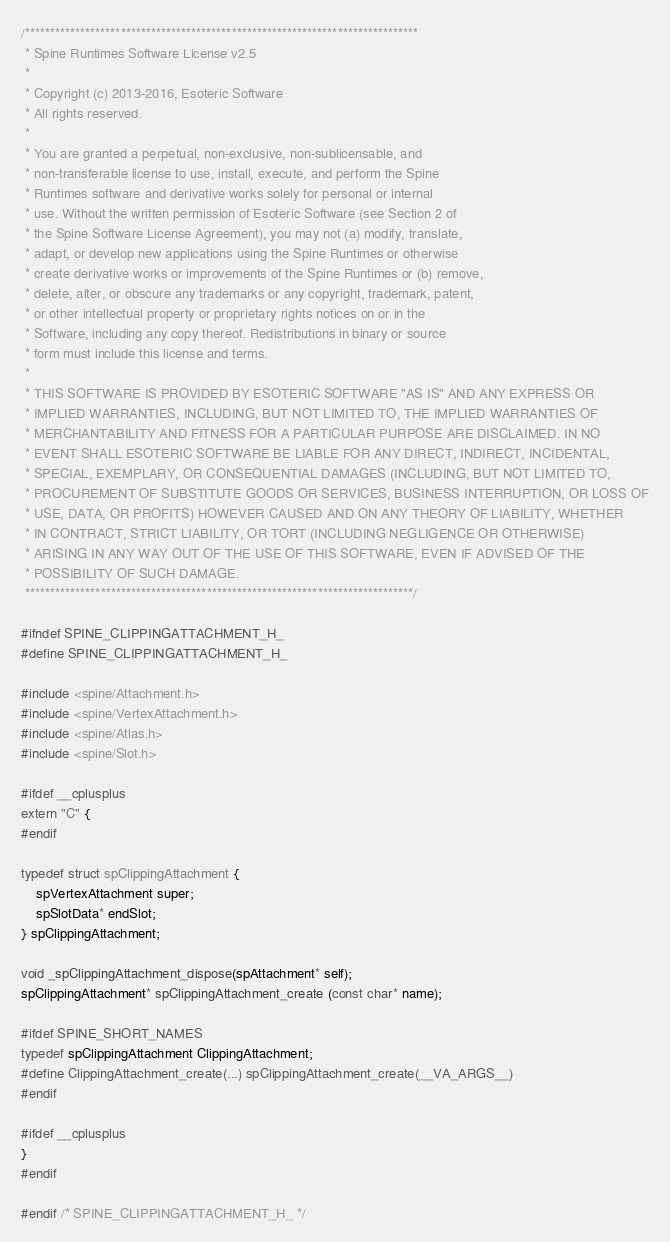<code> <loc_0><loc_0><loc_500><loc_500><_C_>/******************************************************************************
 * Spine Runtimes Software License v2.5
 *
 * Copyright (c) 2013-2016, Esoteric Software
 * All rights reserved.
 *
 * You are granted a perpetual, non-exclusive, non-sublicensable, and
 * non-transferable license to use, install, execute, and perform the Spine
 * Runtimes software and derivative works solely for personal or internal
 * use. Without the written permission of Esoteric Software (see Section 2 of
 * the Spine Software License Agreement), you may not (a) modify, translate,
 * adapt, or develop new applications using the Spine Runtimes or otherwise
 * create derivative works or improvements of the Spine Runtimes or (b) remove,
 * delete, alter, or obscure any trademarks or any copyright, trademark, patent,
 * or other intellectual property or proprietary rights notices on or in the
 * Software, including any copy thereof. Redistributions in binary or source
 * form must include this license and terms.
 *
 * THIS SOFTWARE IS PROVIDED BY ESOTERIC SOFTWARE "AS IS" AND ANY EXPRESS OR
 * IMPLIED WARRANTIES, INCLUDING, BUT NOT LIMITED TO, THE IMPLIED WARRANTIES OF
 * MERCHANTABILITY AND FITNESS FOR A PARTICULAR PURPOSE ARE DISCLAIMED. IN NO
 * EVENT SHALL ESOTERIC SOFTWARE BE LIABLE FOR ANY DIRECT, INDIRECT, INCIDENTAL,
 * SPECIAL, EXEMPLARY, OR CONSEQUENTIAL DAMAGES (INCLUDING, BUT NOT LIMITED TO,
 * PROCUREMENT OF SUBSTITUTE GOODS OR SERVICES, BUSINESS INTERRUPTION, OR LOSS OF
 * USE, DATA, OR PROFITS) HOWEVER CAUSED AND ON ANY THEORY OF LIABILITY, WHETHER
 * IN CONTRACT, STRICT LIABILITY, OR TORT (INCLUDING NEGLIGENCE OR OTHERWISE)
 * ARISING IN ANY WAY OUT OF THE USE OF THIS SOFTWARE, EVEN IF ADVISED OF THE
 * POSSIBILITY OF SUCH DAMAGE.
 *****************************************************************************/

#ifndef SPINE_CLIPPINGATTACHMENT_H_
#define SPINE_CLIPPINGATTACHMENT_H_

#include <spine/Attachment.h>
#include <spine/VertexAttachment.h>
#include <spine/Atlas.h>
#include <spine/Slot.h>

#ifdef __cplusplus
extern "C" {
#endif

typedef struct spClippingAttachment {
	spVertexAttachment super;
	spSlotData* endSlot;
} spClippingAttachment;

void _spClippingAttachment_dispose(spAttachment* self);
spClippingAttachment* spClippingAttachment_create (const char* name);

#ifdef SPINE_SHORT_NAMES
typedef spClippingAttachment ClippingAttachment;
#define ClippingAttachment_create(...) spClippingAttachment_create(__VA_ARGS__)
#endif

#ifdef __cplusplus
}
#endif

#endif /* SPINE_CLIPPINGATTACHMENT_H_ */
</code> 